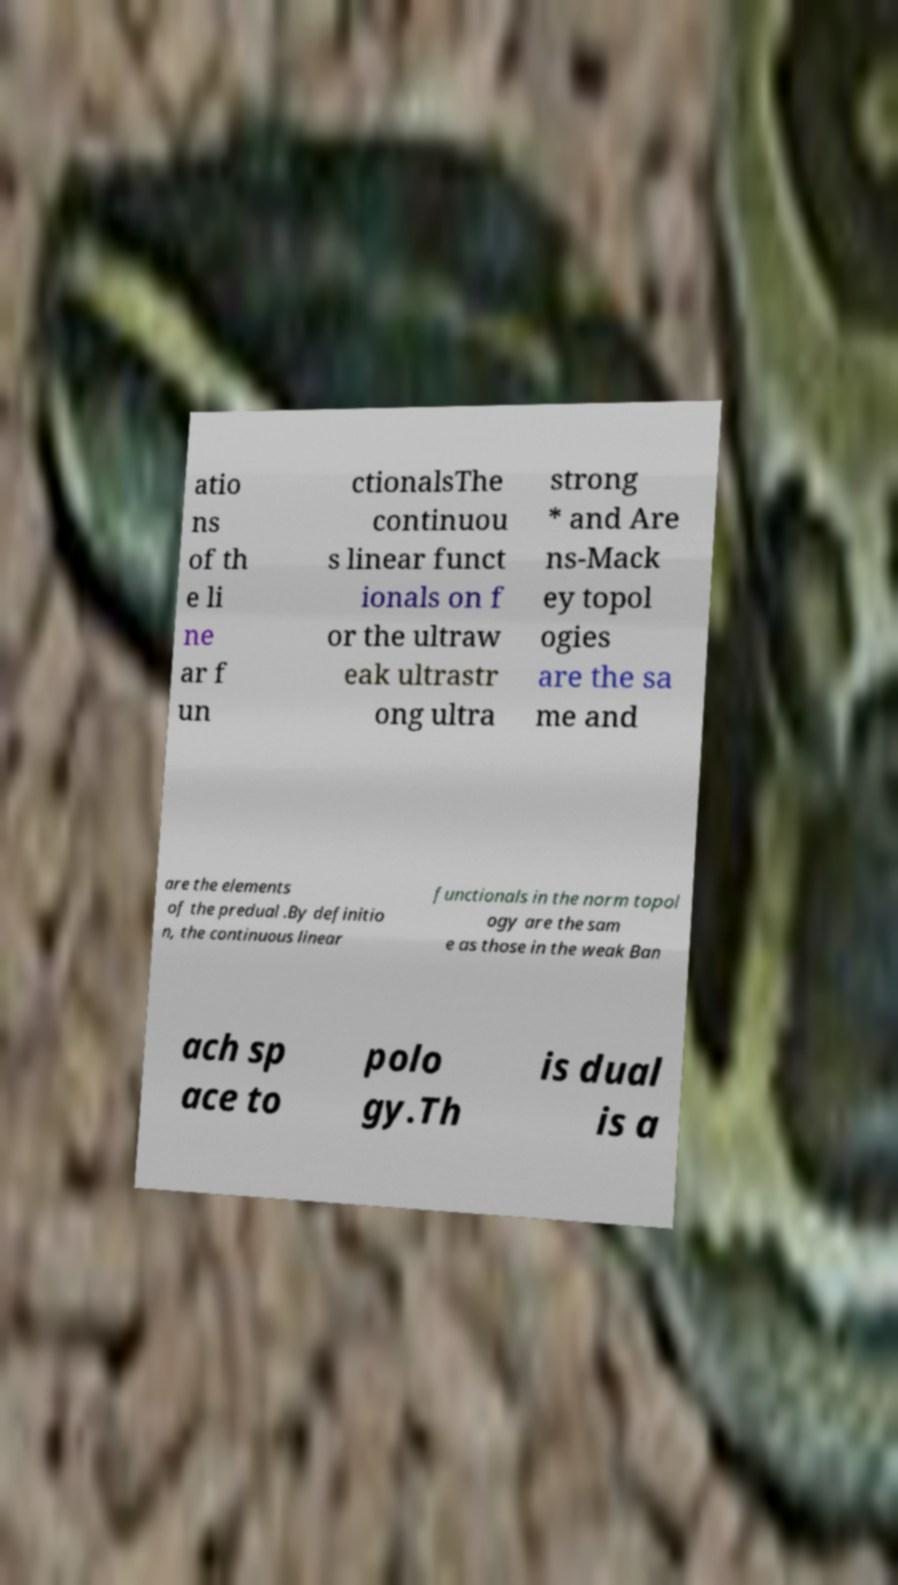Can you accurately transcribe the text from the provided image for me? atio ns of th e li ne ar f un ctionalsThe continuou s linear funct ionals on f or the ultraw eak ultrastr ong ultra strong * and Are ns-Mack ey topol ogies are the sa me and are the elements of the predual .By definitio n, the continuous linear functionals in the norm topol ogy are the sam e as those in the weak Ban ach sp ace to polo gy.Th is dual is a 